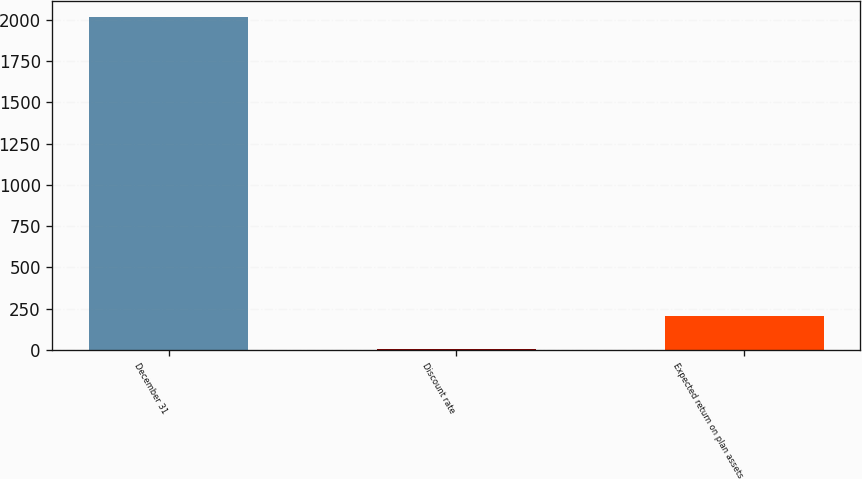<chart> <loc_0><loc_0><loc_500><loc_500><bar_chart><fcel>December 31<fcel>Discount rate<fcel>Expected return on plan assets<nl><fcel>2015<fcel>4.7<fcel>205.73<nl></chart> 